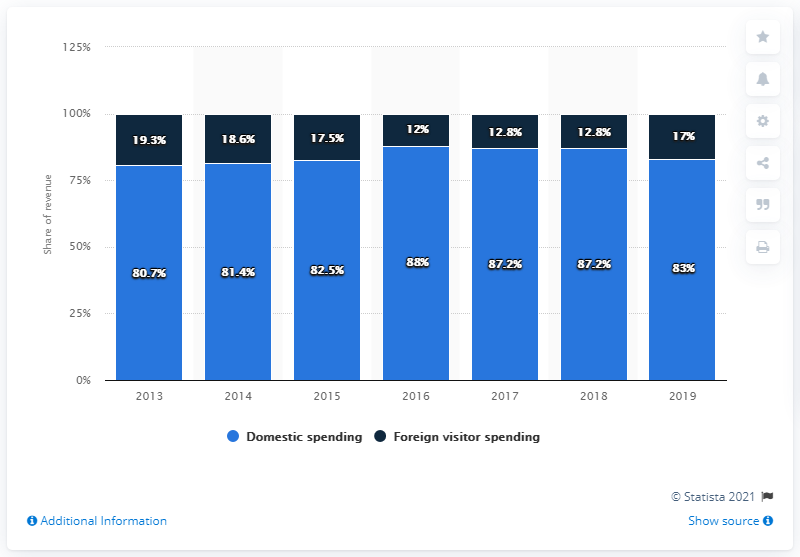List a handful of essential elements in this visual. In 2019, domestic travel spending accounted for 82.5% of the total tourism revenue in India. 